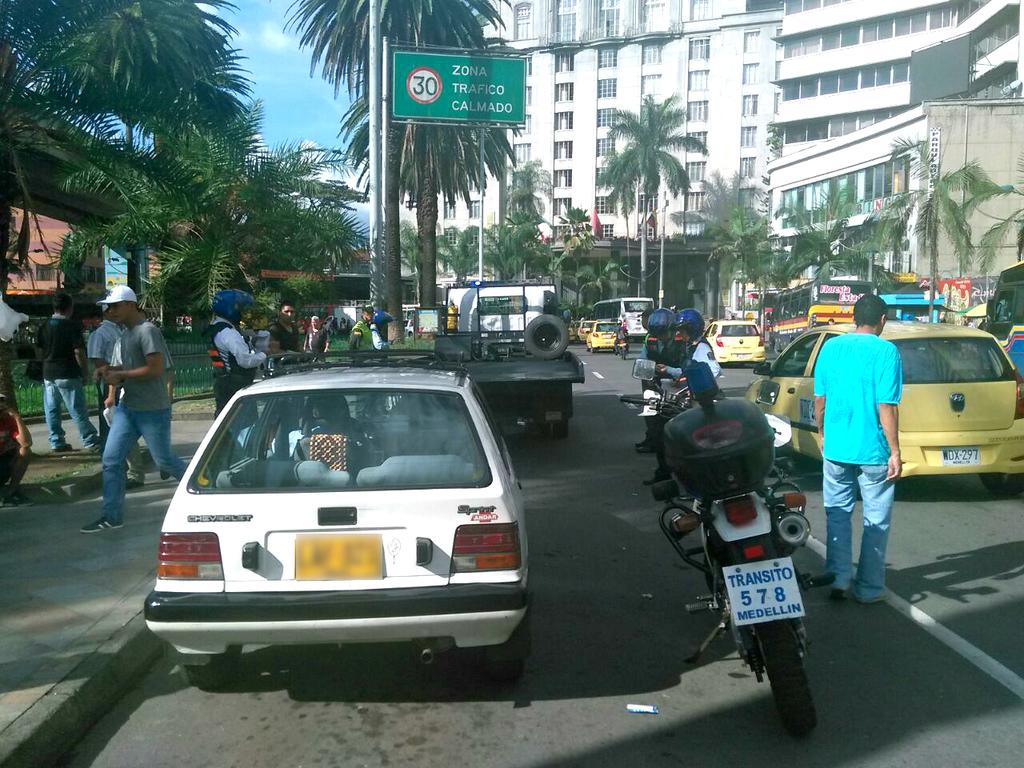<image>
Present a compact description of the photo's key features. A motorcycle with plate number 578 is parked next to a white car along a busy city street with lots of pedestrians. 